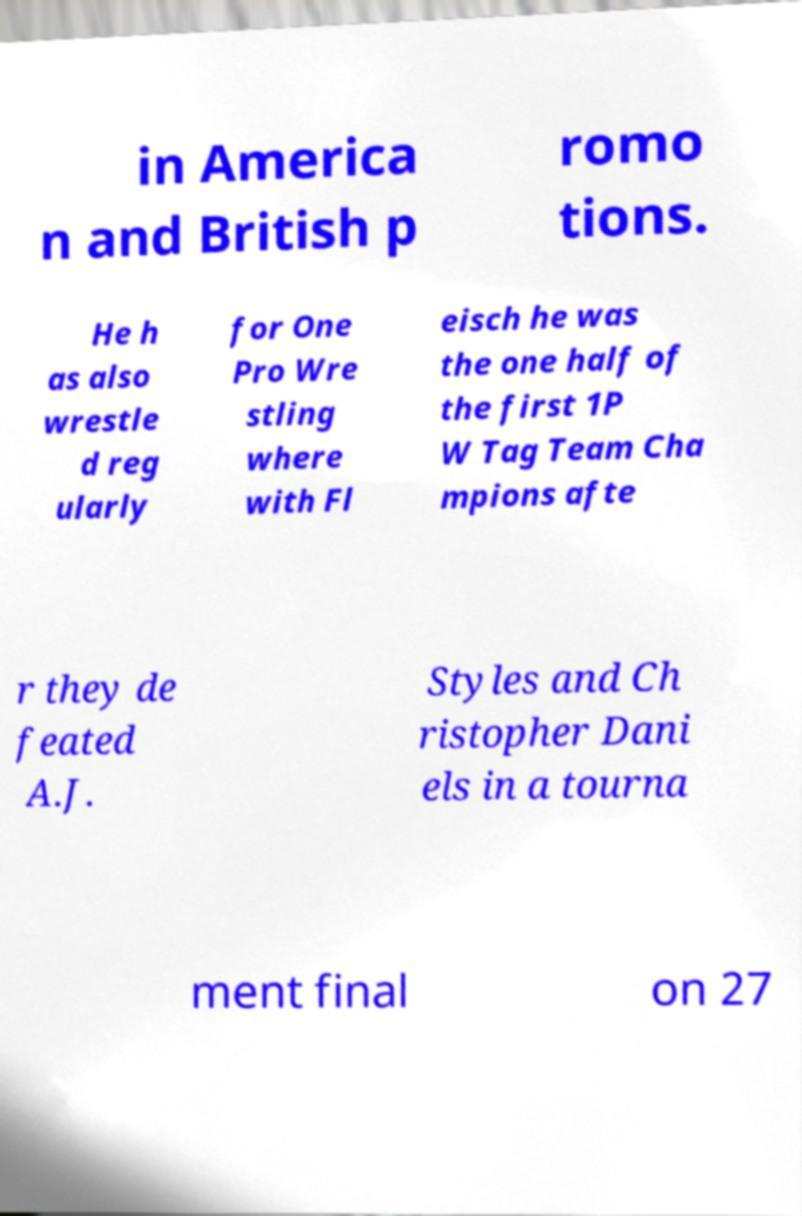Could you extract and type out the text from this image? in America n and British p romo tions. He h as also wrestle d reg ularly for One Pro Wre stling where with Fl eisch he was the one half of the first 1P W Tag Team Cha mpions afte r they de feated A.J. Styles and Ch ristopher Dani els in a tourna ment final on 27 